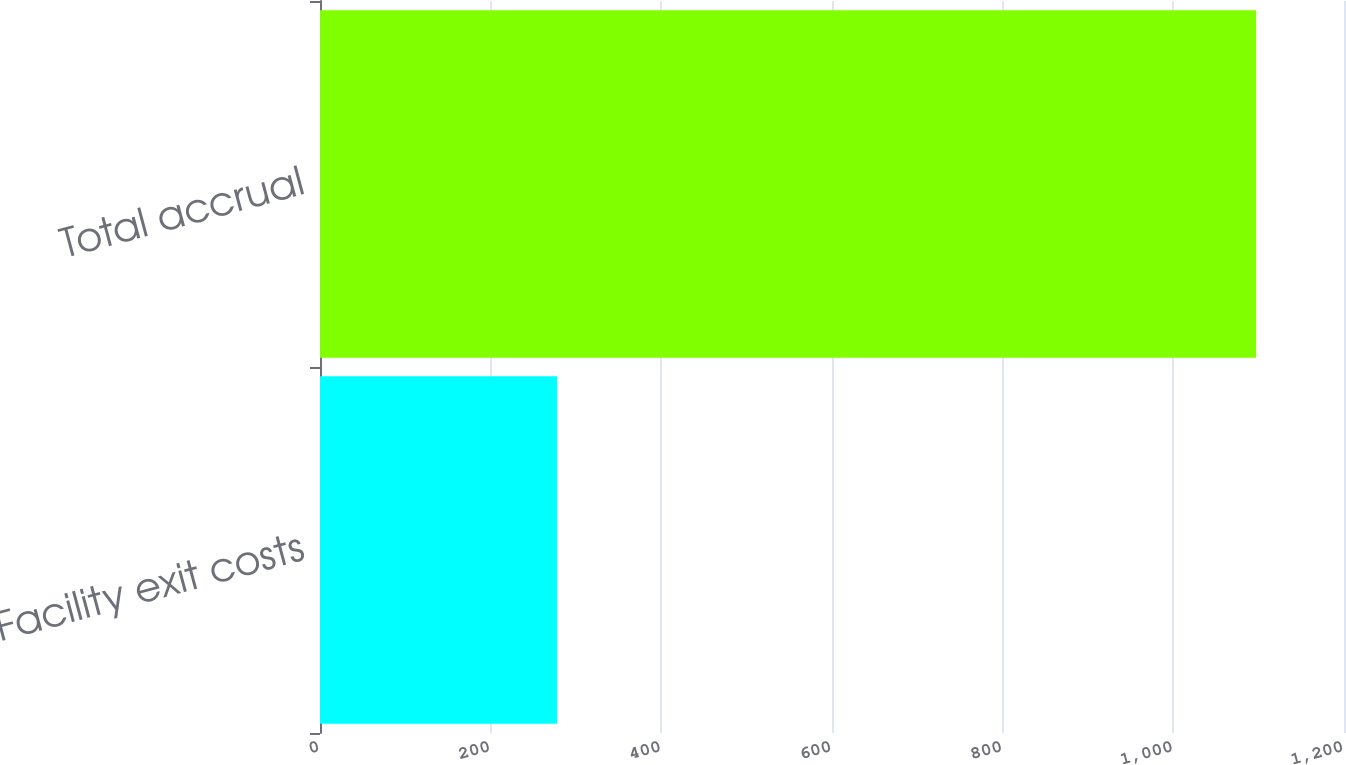<chart> <loc_0><loc_0><loc_500><loc_500><bar_chart><fcel>Facility exit costs<fcel>Total accrual<nl><fcel>278<fcel>1097<nl></chart> 